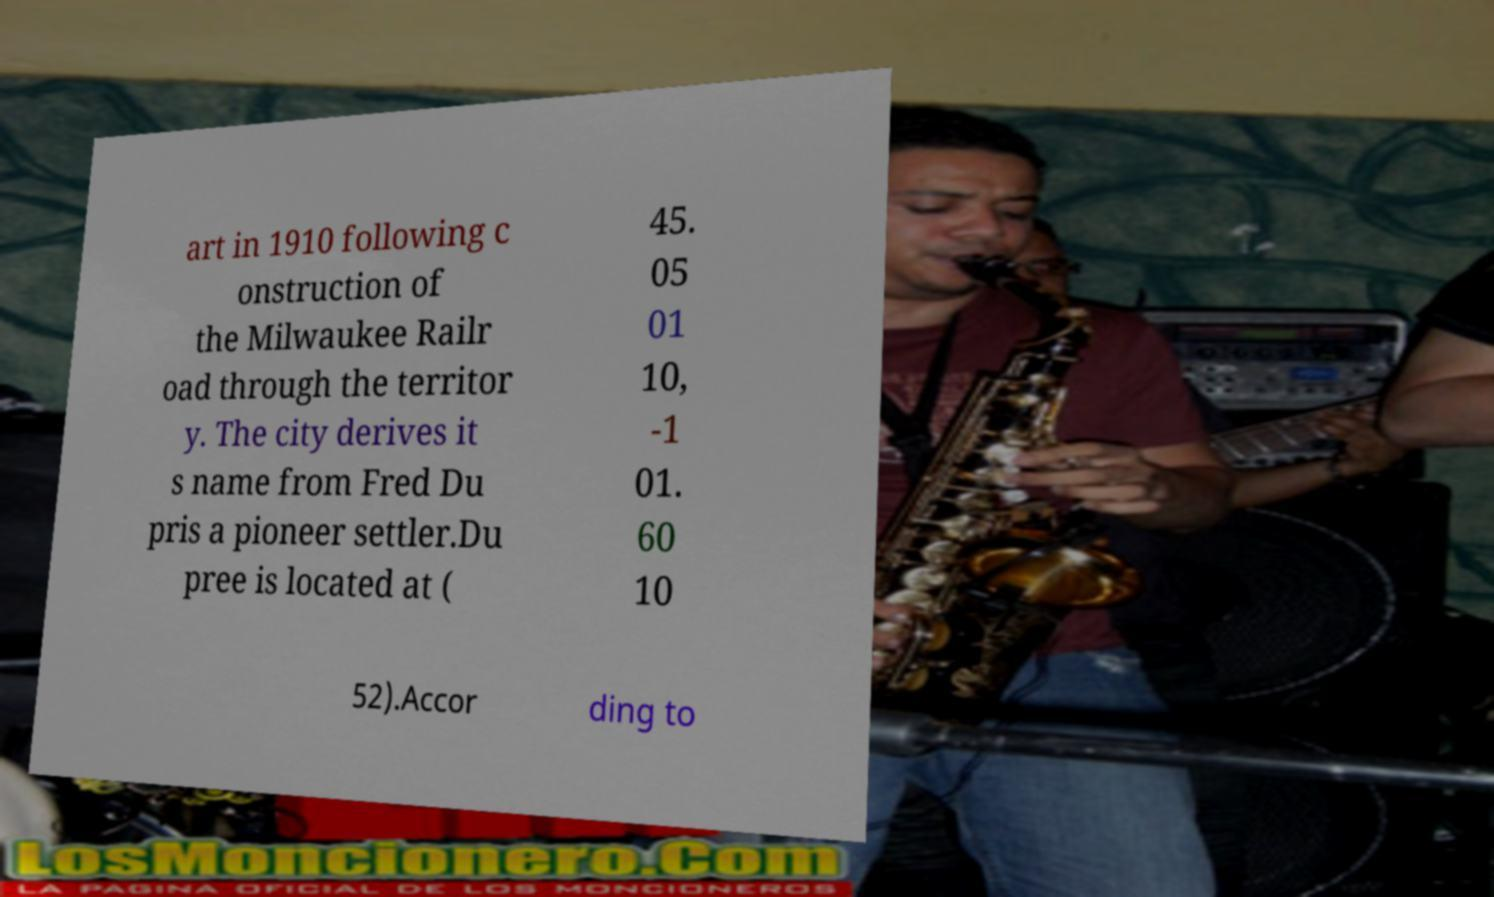There's text embedded in this image that I need extracted. Can you transcribe it verbatim? art in 1910 following c onstruction of the Milwaukee Railr oad through the territor y. The city derives it s name from Fred Du pris a pioneer settler.Du pree is located at ( 45. 05 01 10, -1 01. 60 10 52).Accor ding to 